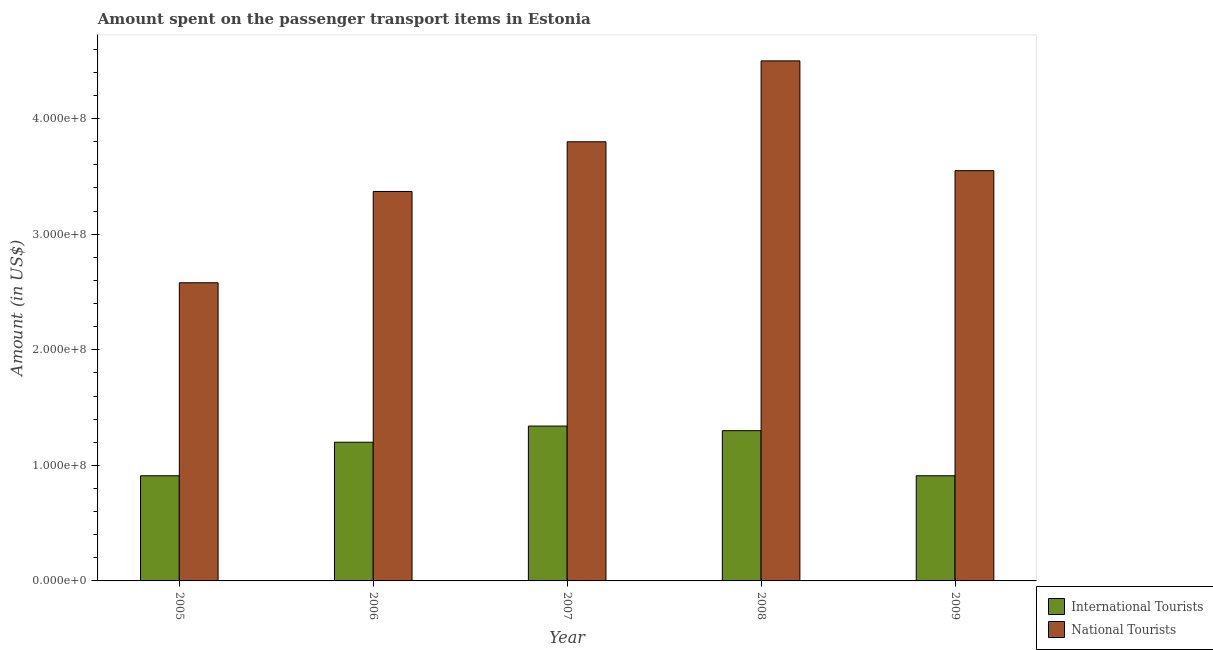How many groups of bars are there?
Your answer should be very brief. 5. Are the number of bars per tick equal to the number of legend labels?
Ensure brevity in your answer.  Yes. Are the number of bars on each tick of the X-axis equal?
Ensure brevity in your answer.  Yes. How many bars are there on the 1st tick from the left?
Offer a very short reply. 2. How many bars are there on the 1st tick from the right?
Offer a terse response. 2. In how many cases, is the number of bars for a given year not equal to the number of legend labels?
Your response must be concise. 0. What is the amount spent on transport items of national tourists in 2008?
Your response must be concise. 4.50e+08. Across all years, what is the maximum amount spent on transport items of national tourists?
Your answer should be very brief. 4.50e+08. Across all years, what is the minimum amount spent on transport items of national tourists?
Keep it short and to the point. 2.58e+08. In which year was the amount spent on transport items of international tourists maximum?
Provide a short and direct response. 2007. In which year was the amount spent on transport items of international tourists minimum?
Provide a short and direct response. 2005. What is the total amount spent on transport items of national tourists in the graph?
Your answer should be compact. 1.78e+09. What is the difference between the amount spent on transport items of national tourists in 2006 and the amount spent on transport items of international tourists in 2009?
Offer a terse response. -1.80e+07. What is the average amount spent on transport items of international tourists per year?
Your answer should be compact. 1.13e+08. In the year 2009, what is the difference between the amount spent on transport items of national tourists and amount spent on transport items of international tourists?
Offer a terse response. 0. What is the difference between the highest and the second highest amount spent on transport items of national tourists?
Make the answer very short. 7.00e+07. What is the difference between the highest and the lowest amount spent on transport items of international tourists?
Offer a terse response. 4.30e+07. What does the 2nd bar from the left in 2008 represents?
Ensure brevity in your answer.  National Tourists. What does the 2nd bar from the right in 2009 represents?
Make the answer very short. International Tourists. Are all the bars in the graph horizontal?
Provide a succinct answer. No. How many years are there in the graph?
Ensure brevity in your answer.  5. Does the graph contain grids?
Provide a succinct answer. No. Where does the legend appear in the graph?
Offer a very short reply. Bottom right. How many legend labels are there?
Offer a terse response. 2. How are the legend labels stacked?
Keep it short and to the point. Vertical. What is the title of the graph?
Provide a succinct answer. Amount spent on the passenger transport items in Estonia. Does "Lowest 20% of population" appear as one of the legend labels in the graph?
Provide a succinct answer. No. What is the label or title of the X-axis?
Make the answer very short. Year. What is the label or title of the Y-axis?
Your response must be concise. Amount (in US$). What is the Amount (in US$) in International Tourists in 2005?
Offer a very short reply. 9.10e+07. What is the Amount (in US$) in National Tourists in 2005?
Give a very brief answer. 2.58e+08. What is the Amount (in US$) of International Tourists in 2006?
Ensure brevity in your answer.  1.20e+08. What is the Amount (in US$) in National Tourists in 2006?
Your answer should be very brief. 3.37e+08. What is the Amount (in US$) of International Tourists in 2007?
Offer a very short reply. 1.34e+08. What is the Amount (in US$) in National Tourists in 2007?
Your answer should be very brief. 3.80e+08. What is the Amount (in US$) of International Tourists in 2008?
Give a very brief answer. 1.30e+08. What is the Amount (in US$) of National Tourists in 2008?
Your answer should be compact. 4.50e+08. What is the Amount (in US$) of International Tourists in 2009?
Make the answer very short. 9.10e+07. What is the Amount (in US$) of National Tourists in 2009?
Keep it short and to the point. 3.55e+08. Across all years, what is the maximum Amount (in US$) of International Tourists?
Your answer should be compact. 1.34e+08. Across all years, what is the maximum Amount (in US$) of National Tourists?
Offer a very short reply. 4.50e+08. Across all years, what is the minimum Amount (in US$) in International Tourists?
Offer a very short reply. 9.10e+07. Across all years, what is the minimum Amount (in US$) in National Tourists?
Your answer should be very brief. 2.58e+08. What is the total Amount (in US$) in International Tourists in the graph?
Offer a terse response. 5.66e+08. What is the total Amount (in US$) of National Tourists in the graph?
Make the answer very short. 1.78e+09. What is the difference between the Amount (in US$) of International Tourists in 2005 and that in 2006?
Provide a succinct answer. -2.90e+07. What is the difference between the Amount (in US$) of National Tourists in 2005 and that in 2006?
Keep it short and to the point. -7.90e+07. What is the difference between the Amount (in US$) of International Tourists in 2005 and that in 2007?
Give a very brief answer. -4.30e+07. What is the difference between the Amount (in US$) in National Tourists in 2005 and that in 2007?
Your answer should be very brief. -1.22e+08. What is the difference between the Amount (in US$) of International Tourists in 2005 and that in 2008?
Provide a succinct answer. -3.90e+07. What is the difference between the Amount (in US$) in National Tourists in 2005 and that in 2008?
Offer a terse response. -1.92e+08. What is the difference between the Amount (in US$) of National Tourists in 2005 and that in 2009?
Provide a short and direct response. -9.70e+07. What is the difference between the Amount (in US$) of International Tourists in 2006 and that in 2007?
Give a very brief answer. -1.40e+07. What is the difference between the Amount (in US$) in National Tourists in 2006 and that in 2007?
Keep it short and to the point. -4.30e+07. What is the difference between the Amount (in US$) of International Tourists in 2006 and that in 2008?
Offer a terse response. -1.00e+07. What is the difference between the Amount (in US$) in National Tourists in 2006 and that in 2008?
Provide a short and direct response. -1.13e+08. What is the difference between the Amount (in US$) of International Tourists in 2006 and that in 2009?
Your response must be concise. 2.90e+07. What is the difference between the Amount (in US$) in National Tourists in 2006 and that in 2009?
Offer a terse response. -1.80e+07. What is the difference between the Amount (in US$) of National Tourists in 2007 and that in 2008?
Make the answer very short. -7.00e+07. What is the difference between the Amount (in US$) in International Tourists in 2007 and that in 2009?
Offer a terse response. 4.30e+07. What is the difference between the Amount (in US$) in National Tourists in 2007 and that in 2009?
Your response must be concise. 2.50e+07. What is the difference between the Amount (in US$) in International Tourists in 2008 and that in 2009?
Keep it short and to the point. 3.90e+07. What is the difference between the Amount (in US$) in National Tourists in 2008 and that in 2009?
Make the answer very short. 9.50e+07. What is the difference between the Amount (in US$) of International Tourists in 2005 and the Amount (in US$) of National Tourists in 2006?
Your answer should be very brief. -2.46e+08. What is the difference between the Amount (in US$) of International Tourists in 2005 and the Amount (in US$) of National Tourists in 2007?
Your answer should be very brief. -2.89e+08. What is the difference between the Amount (in US$) of International Tourists in 2005 and the Amount (in US$) of National Tourists in 2008?
Make the answer very short. -3.59e+08. What is the difference between the Amount (in US$) in International Tourists in 2005 and the Amount (in US$) in National Tourists in 2009?
Your response must be concise. -2.64e+08. What is the difference between the Amount (in US$) of International Tourists in 2006 and the Amount (in US$) of National Tourists in 2007?
Provide a short and direct response. -2.60e+08. What is the difference between the Amount (in US$) in International Tourists in 2006 and the Amount (in US$) in National Tourists in 2008?
Your answer should be very brief. -3.30e+08. What is the difference between the Amount (in US$) of International Tourists in 2006 and the Amount (in US$) of National Tourists in 2009?
Ensure brevity in your answer.  -2.35e+08. What is the difference between the Amount (in US$) of International Tourists in 2007 and the Amount (in US$) of National Tourists in 2008?
Ensure brevity in your answer.  -3.16e+08. What is the difference between the Amount (in US$) of International Tourists in 2007 and the Amount (in US$) of National Tourists in 2009?
Make the answer very short. -2.21e+08. What is the difference between the Amount (in US$) in International Tourists in 2008 and the Amount (in US$) in National Tourists in 2009?
Ensure brevity in your answer.  -2.25e+08. What is the average Amount (in US$) in International Tourists per year?
Your answer should be compact. 1.13e+08. What is the average Amount (in US$) in National Tourists per year?
Your answer should be compact. 3.56e+08. In the year 2005, what is the difference between the Amount (in US$) in International Tourists and Amount (in US$) in National Tourists?
Make the answer very short. -1.67e+08. In the year 2006, what is the difference between the Amount (in US$) in International Tourists and Amount (in US$) in National Tourists?
Your answer should be compact. -2.17e+08. In the year 2007, what is the difference between the Amount (in US$) of International Tourists and Amount (in US$) of National Tourists?
Make the answer very short. -2.46e+08. In the year 2008, what is the difference between the Amount (in US$) in International Tourists and Amount (in US$) in National Tourists?
Make the answer very short. -3.20e+08. In the year 2009, what is the difference between the Amount (in US$) in International Tourists and Amount (in US$) in National Tourists?
Your answer should be compact. -2.64e+08. What is the ratio of the Amount (in US$) in International Tourists in 2005 to that in 2006?
Ensure brevity in your answer.  0.76. What is the ratio of the Amount (in US$) of National Tourists in 2005 to that in 2006?
Give a very brief answer. 0.77. What is the ratio of the Amount (in US$) of International Tourists in 2005 to that in 2007?
Give a very brief answer. 0.68. What is the ratio of the Amount (in US$) of National Tourists in 2005 to that in 2007?
Your answer should be very brief. 0.68. What is the ratio of the Amount (in US$) in National Tourists in 2005 to that in 2008?
Provide a short and direct response. 0.57. What is the ratio of the Amount (in US$) in National Tourists in 2005 to that in 2009?
Your response must be concise. 0.73. What is the ratio of the Amount (in US$) in International Tourists in 2006 to that in 2007?
Offer a very short reply. 0.9. What is the ratio of the Amount (in US$) in National Tourists in 2006 to that in 2007?
Give a very brief answer. 0.89. What is the ratio of the Amount (in US$) in National Tourists in 2006 to that in 2008?
Provide a short and direct response. 0.75. What is the ratio of the Amount (in US$) of International Tourists in 2006 to that in 2009?
Offer a terse response. 1.32. What is the ratio of the Amount (in US$) in National Tourists in 2006 to that in 2009?
Offer a terse response. 0.95. What is the ratio of the Amount (in US$) in International Tourists in 2007 to that in 2008?
Offer a very short reply. 1.03. What is the ratio of the Amount (in US$) of National Tourists in 2007 to that in 2008?
Your answer should be compact. 0.84. What is the ratio of the Amount (in US$) of International Tourists in 2007 to that in 2009?
Provide a short and direct response. 1.47. What is the ratio of the Amount (in US$) of National Tourists in 2007 to that in 2009?
Ensure brevity in your answer.  1.07. What is the ratio of the Amount (in US$) of International Tourists in 2008 to that in 2009?
Your response must be concise. 1.43. What is the ratio of the Amount (in US$) of National Tourists in 2008 to that in 2009?
Your answer should be very brief. 1.27. What is the difference between the highest and the second highest Amount (in US$) of International Tourists?
Keep it short and to the point. 4.00e+06. What is the difference between the highest and the second highest Amount (in US$) of National Tourists?
Give a very brief answer. 7.00e+07. What is the difference between the highest and the lowest Amount (in US$) of International Tourists?
Your response must be concise. 4.30e+07. What is the difference between the highest and the lowest Amount (in US$) of National Tourists?
Give a very brief answer. 1.92e+08. 